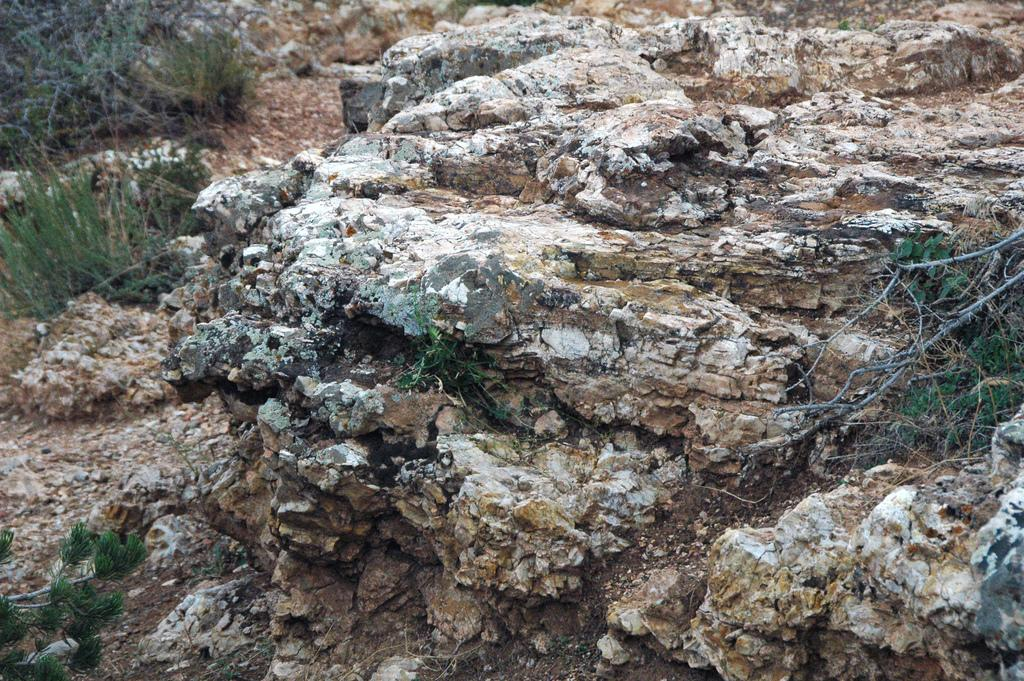What type of surface is visible in the image? There is a rock surface in the image. What type of vegetation can be seen in the image? There is grass in the image. What type of fang can be seen in the image? There is no fang present in the image. What belief is depicted in the image? The image does not depict any beliefs; it shows a rock surface and grass. 